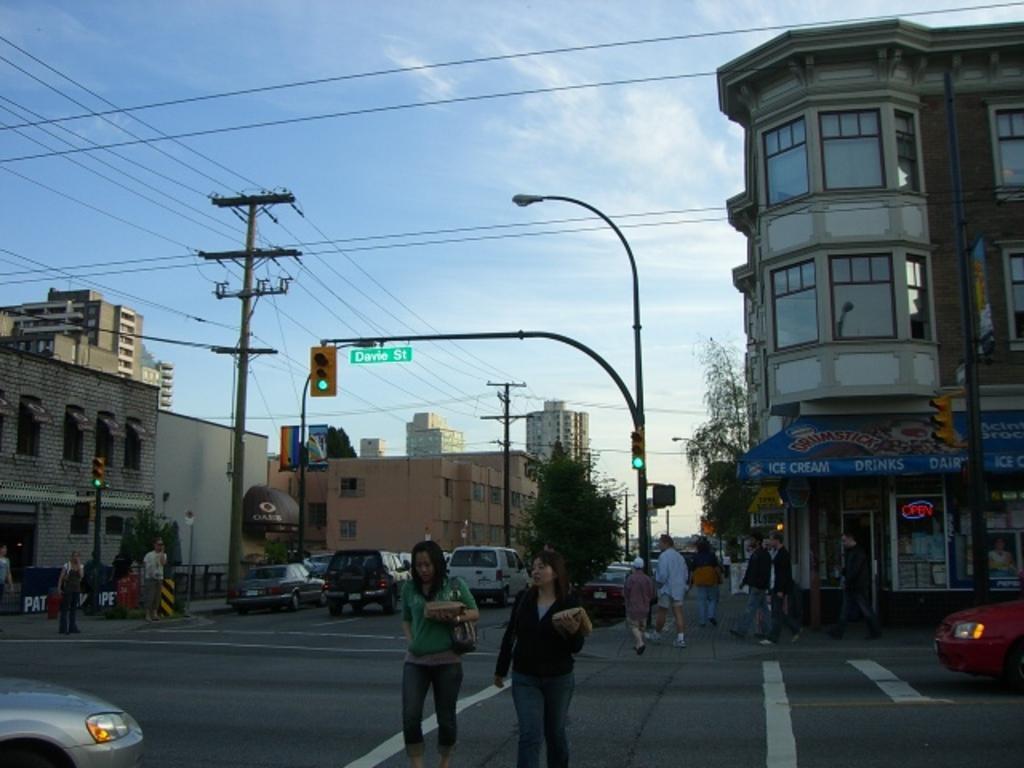How would you summarize this image in a sentence or two? In this there are two women who are walking on the road. On the left I can see the electric poles and wires are connected. In the background I can see many trees, poles, buildings and cars. At the top I can see the sky and clouds. 